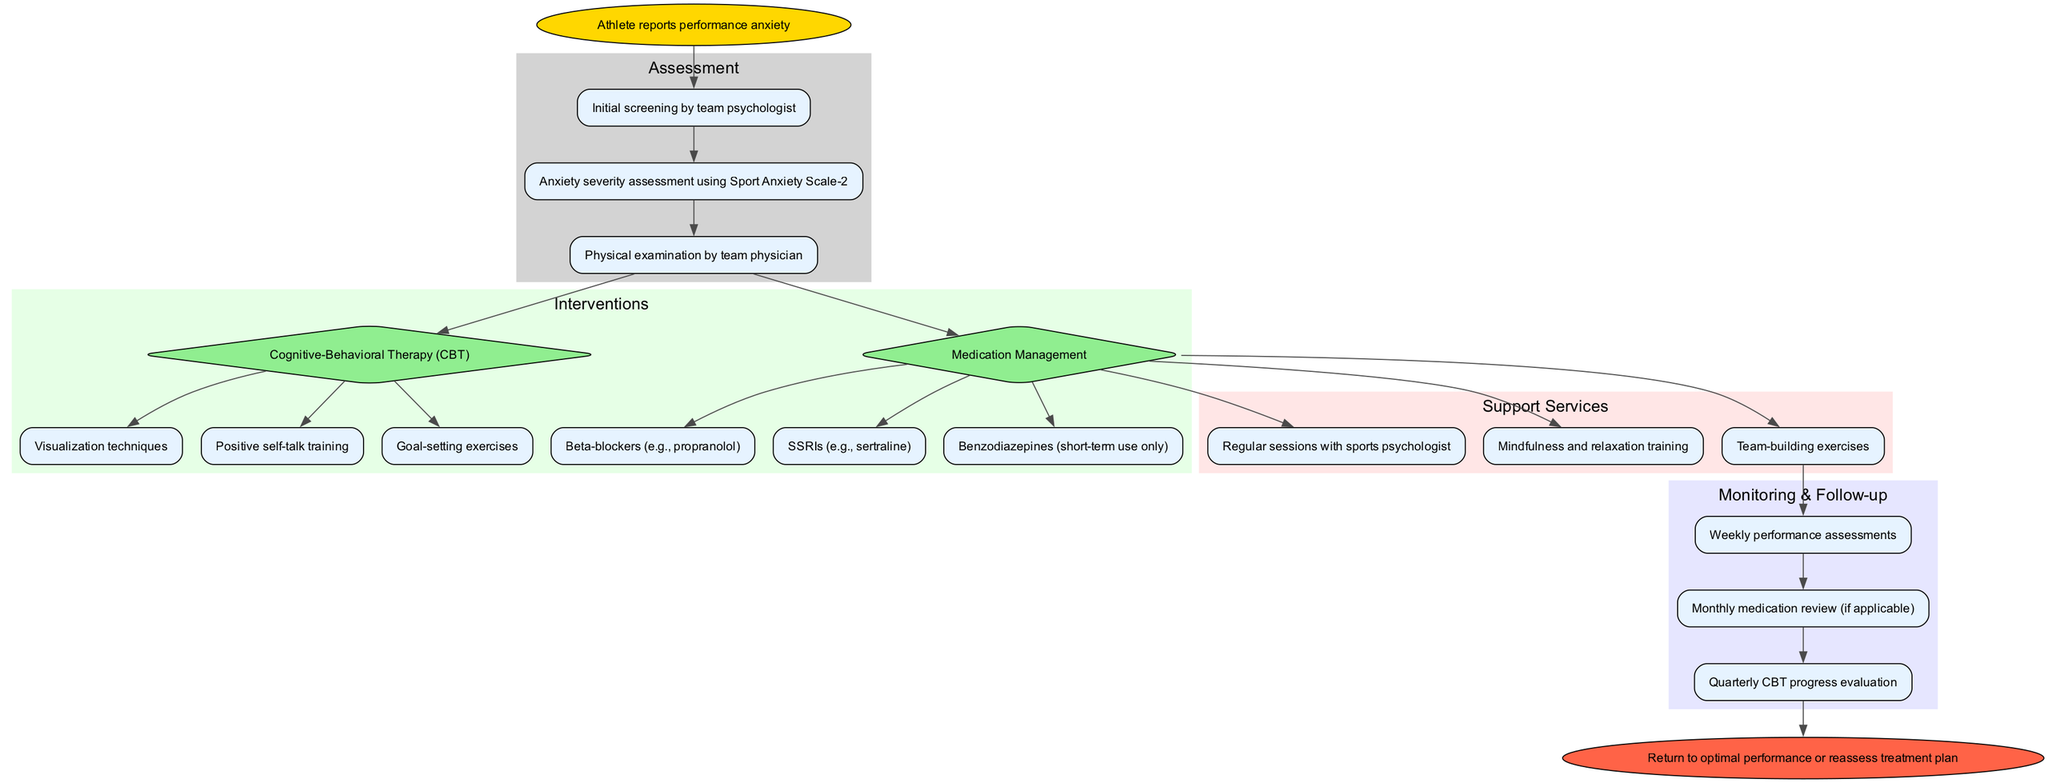What is the starting point of the clinical pathway? The starting point is indicated as "Athlete reports performance anxiety." This is the first node in the diagram, marking the beginning of the pathway.
Answer: Athlete reports performance anxiety How many assessment steps are there in the pathway? By counting the nodes listed under the assessment steps in the diagram, there are three steps: initial screening, severity assessment, and physical examination.
Answer: 3 Which intervention is primarily focused on cognitive-behavioral techniques? The intervention named "Cognitive-Behavioral Therapy (CBT)" is designated for cognitive-behavioral techniques. This is evident from the intervention list where CBT is the only one specialized in cognitive skills.
Answer: Cognitive-Behavioral Therapy (CBT) What is the end point of the clinical pathway? The end point is shown as "Return to optimal performance or reassess treatment plan." This node signifies the conclusion of the pathway where the results of the interventions are evaluated.
Answer: Return to optimal performance or reassess treatment plan What type of medication options are included in the pathway's interventions? The intervention for medication management includes options like Beta-blockers, SSRIs, and Benzodiazepines. These are specifically listed as the pharmacological options available for managing performance anxiety.
Answer: Beta-blockers, SSRIs, Benzodiazepines How often are performance assessments conducted according to the monitoring section? The monitoring section specifies that performance assessments are conducted weekly, as indicated in the associated node.
Answer: Weekly What type of follow-up is included after the support services? After receiving support services, the follow-up is structured around monitoring. Specifically, it includes weekly performance assessments and quarterly CBT progress evaluation, as noted in the respective nodes.
Answer: Monitoring What kind of services are listed under support services? The support services mentioned in the pathway include regular sessions with a sports psychologist, mindfulness and relaxation training, and team-building exercises. These categorically provide various forms of psychological and team support.
Answer: Regular sessions with sports psychologist, mindfulness and relaxation training, team-building exercises What assessment tool is used to measure anxiety severity? The assessment tool specified for measuring anxiety severity is the Sport Anxiety Scale-2, which is detailed among the assessment steps.
Answer: Sport Anxiety Scale-2 